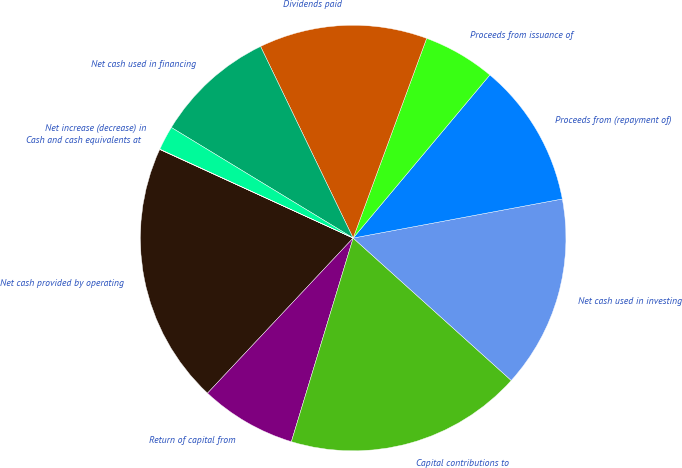Convert chart. <chart><loc_0><loc_0><loc_500><loc_500><pie_chart><fcel>Net cash provided by operating<fcel>Return of capital from<fcel>Capital contributions to<fcel>Net cash used in investing<fcel>Proceeds from (repayment of)<fcel>Proceeds from issuance of<fcel>Dividends paid<fcel>Net cash used in financing<fcel>Net increase (decrease) in<fcel>Cash and cash equivalents at<nl><fcel>19.84%<fcel>7.31%<fcel>18.02%<fcel>14.61%<fcel>10.96%<fcel>5.49%<fcel>12.78%<fcel>9.14%<fcel>1.84%<fcel>0.02%<nl></chart> 